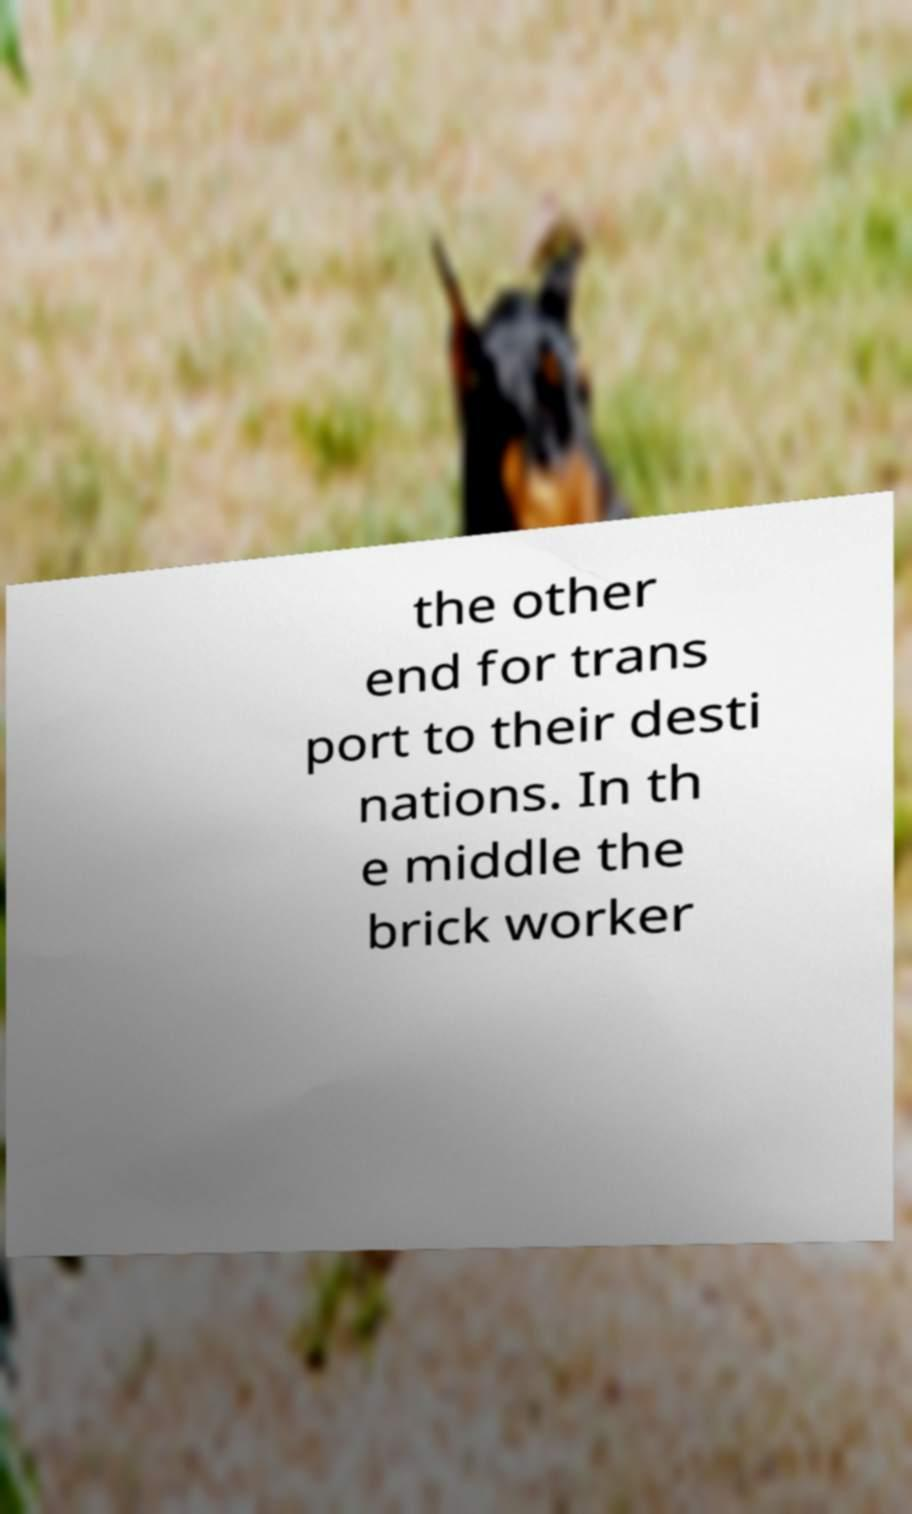There's text embedded in this image that I need extracted. Can you transcribe it verbatim? the other end for trans port to their desti nations. In th e middle the brick worker 